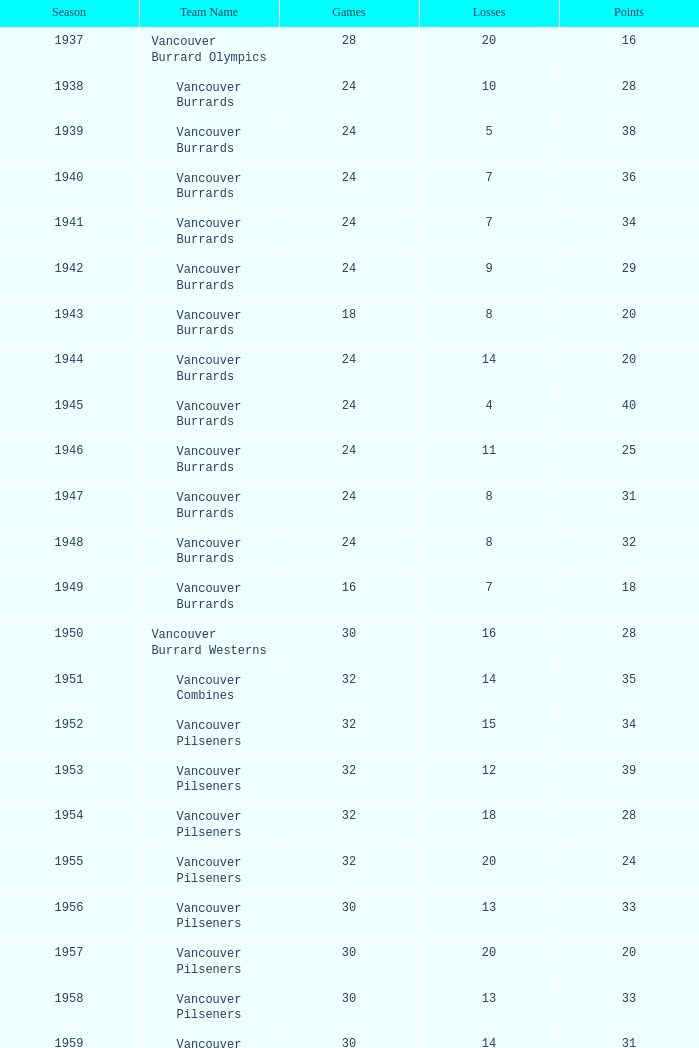How many points have the vancouver carlings accumulated with under 12 losses and more than 32 games played? 0.0. 